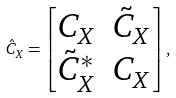<formula> <loc_0><loc_0><loc_500><loc_500>{ \hat { C } } _ { X } = \begin{bmatrix} C _ { X } & \tilde { C } _ { X } \\ \tilde { C } ^ { * } _ { X } & C _ { X } \end{bmatrix} ,</formula> 